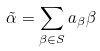<formula> <loc_0><loc_0><loc_500><loc_500>\tilde { \alpha } = \sum _ { \beta \in S } a _ { \beta } \beta</formula> 